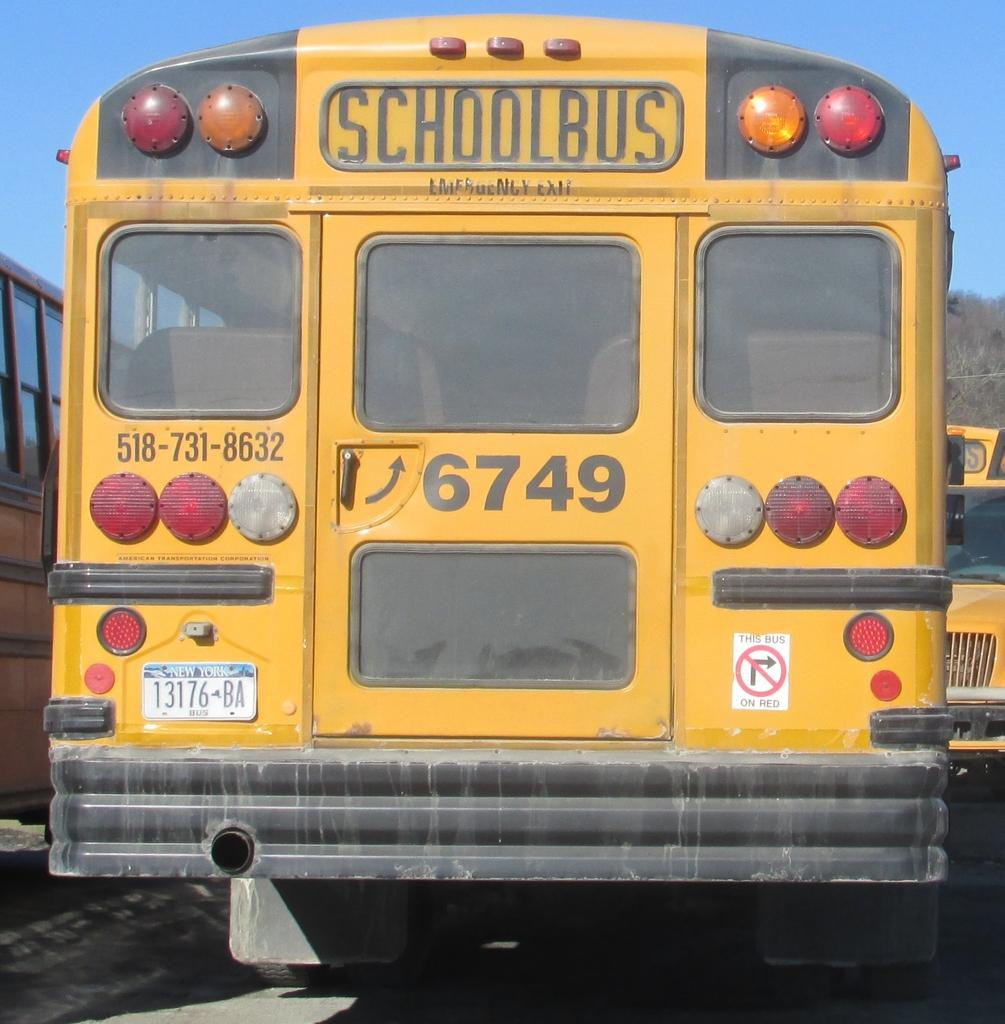Provide a one-sentence caption for the provided image. Back of a schoolbus with the numbers 6749 on it. 